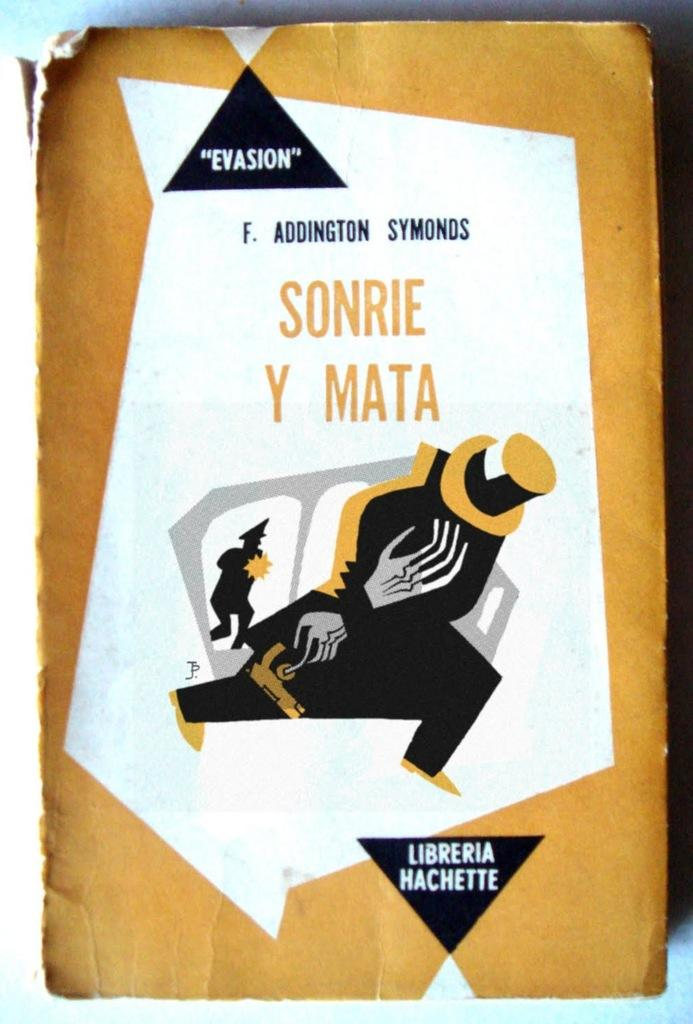<image>
Render a clear and concise summary of the photo. the word sonrie that is on a white background 